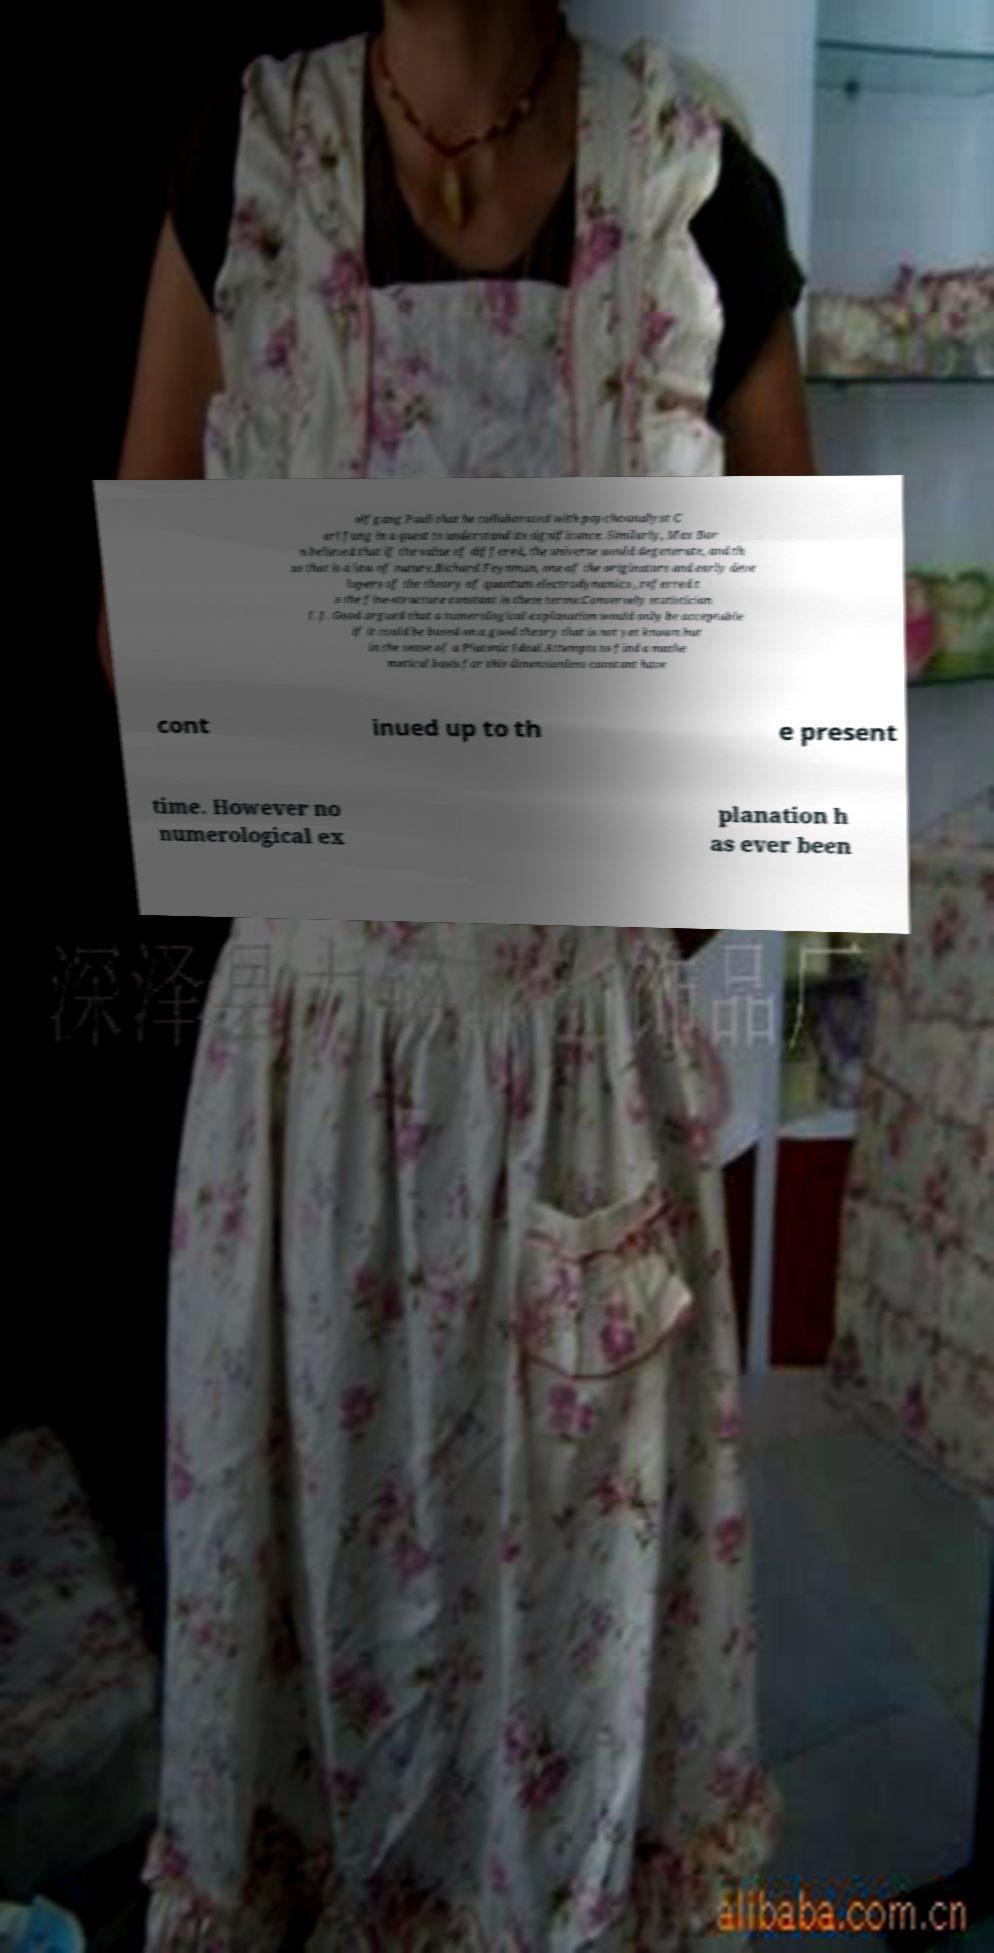Please read and relay the text visible in this image. What does it say? olfgang Pauli that he collaborated with psychoanalyst C arl Jung in a quest to understand its significance. Similarly, Max Bor n believed that if the value of differed, the universe would degenerate, and th us that is a law of nature.Richard Feynman, one of the originators and early deve lopers of the theory of quantum electrodynamics , referred t o the fine-structure constant in these terms:Conversely statistician I. J. Good argued that a numerological explanation would only be acceptable if it could be based on a good theory that is not yet known but in the sense of a Platonic Ideal.Attempts to find a mathe matical basis for this dimensionless constant have cont inued up to th e present time. However no numerological ex planation h as ever been 